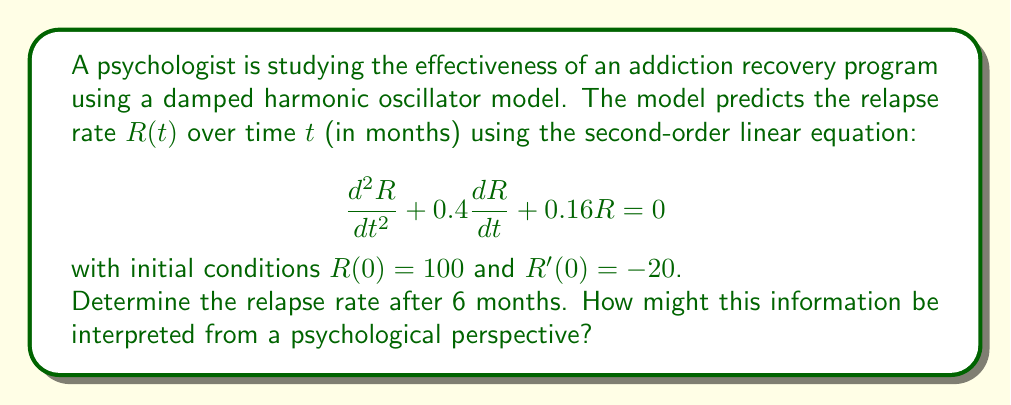Show me your answer to this math problem. To solve this problem, we follow these steps:

1) The general solution for this damped harmonic oscillator equation is:

   $$R(t) = e^{-\lambda t}(A\cos(\omega t) + B\sin(\omega t))$$

   where $\lambda = 0.2$ (half of the coefficient of $\frac{dR}{dt}$) and $\omega = \sqrt{0.16 - \lambda^2} = 0.2$.

2) Using the initial conditions:
   $R(0) = 100$ gives us $A = 100$
   $R'(0) = -20$ gives us $B = 0$

3) Therefore, our specific solution is:

   $$R(t) = 100e^{-0.2t}\cos(0.2t)$$

4) To find the relapse rate after 6 months, we substitute $t = 6$:

   $$R(6) = 100e^{-0.2(6)}\cos(0.2(6))$$
   $$= 100e^{-1.2}\cos(1.2)$$
   $$\approx 30.13$$

5) From a psychological perspective, this result indicates that after 6 months, the relapse rate has decreased to about 30.13% of its initial value. This suggests that the recovery program has been effective in reducing relapse tendencies over time.

   The damped oscillatory nature of the model also implies that while there may be fluctuations in relapse risk, the overall trend is towards recovery. This aligns with the understanding that addiction recovery is often a non-linear process with periods of progress and setbacks.
Answer: The relapse rate after 6 months is approximately 30.13% of the initial rate. 